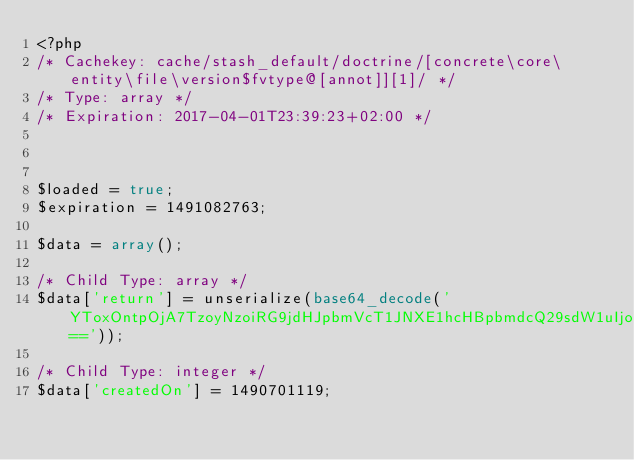Convert code to text. <code><loc_0><loc_0><loc_500><loc_500><_PHP_><?php 
/* Cachekey: cache/stash_default/doctrine/[concrete\core\entity\file\version$fvtype@[annot]][1]/ */
/* Type: array */
/* Expiration: 2017-04-01T23:39:23+02:00 */



$loaded = true;
$expiration = 1491082763;

$data = array();

/* Child Type: array */
$data['return'] = unserialize(base64_decode('YToxOntpOjA7TzoyNzoiRG9jdHJpbmVcT1JNXE1hcHBpbmdcQ29sdW1uIjo5OntzOjQ6Im5hbWUiO047czo0OiJ0eXBlIjtzOjc6ImludGVnZXIiO3M6NjoibGVuZ3RoIjtOO3M6OToicHJlY2lzaW9uIjtpOjA7czo1OiJzY2FsZSI7aTowO3M6NjoidW5pcXVlIjtiOjA7czo4OiJudWxsYWJsZSI7YjowO3M6Nzoib3B0aW9ucyI7YTowOnt9czoxNjoiY29sdW1uRGVmaW5pdGlvbiI7Tjt9fQ=='));

/* Child Type: integer */
$data['createdOn'] = 1490701119;
</code> 